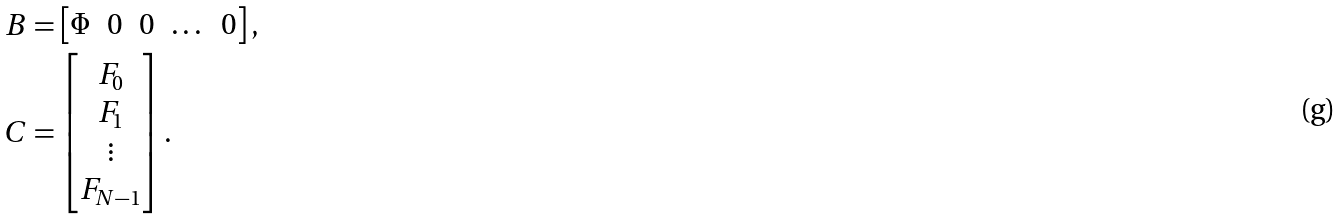<formula> <loc_0><loc_0><loc_500><loc_500>B & = \begin{bmatrix} \Phi & 0 & 0 & \dots & 0 \end{bmatrix} , \\ C & = \begin{bmatrix} F _ { 0 } \\ F _ { 1 } \\ \vdots \\ F _ { N - 1 } \end{bmatrix} .</formula> 